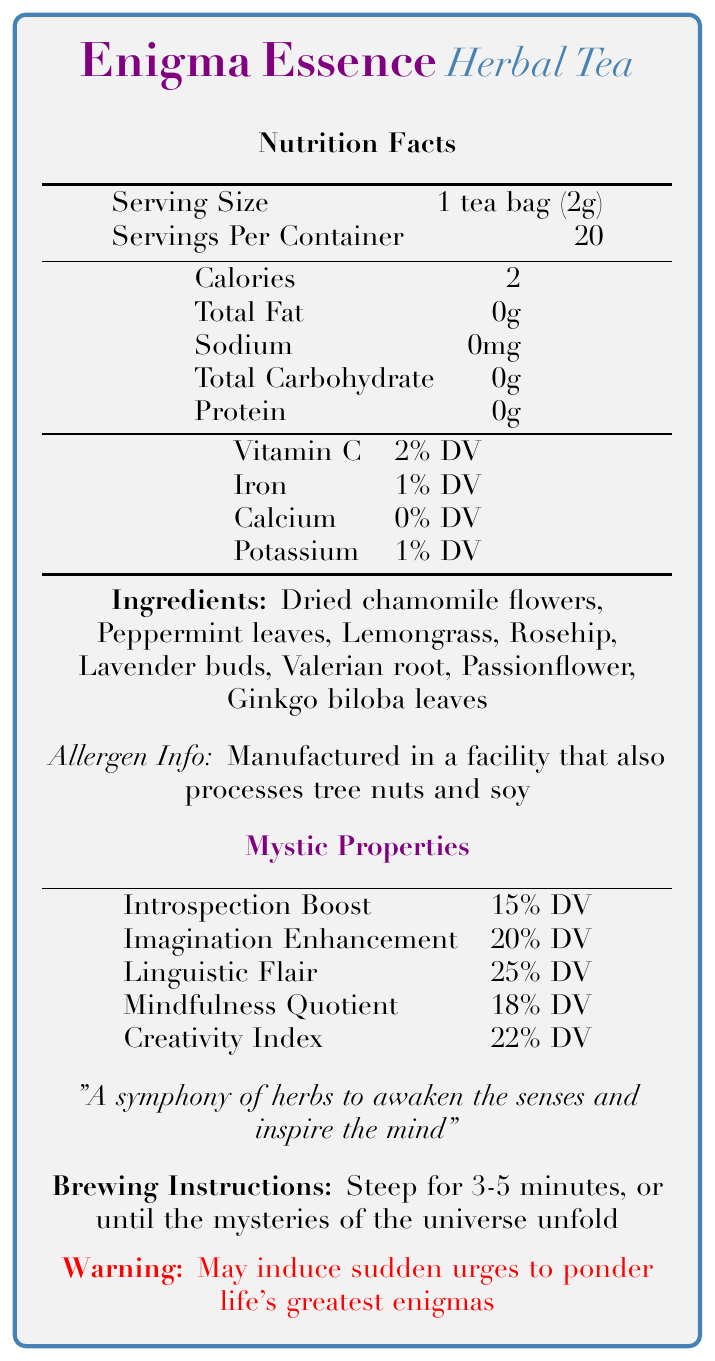what is the serving size of Enigma Essence Herbal Tea? The document states that the serving size is "1 tea bag (2g)."
Answer: 1 tea bag (2g) how many servings are there per container? The document mentions "Servings Per Container" as 20.
Answer: 20 how many calories are present in one serving? The document shows that each serving has "Calories: 2."
Answer: 2 which ingredient is not listed in the tea? A. Valerian root B. Rosehip C. Green tea The provided ingredient list includes Valerian root and Rosehip but not Green tea.
Answer: C how long should you steep the tea? A. 1-2 minutes B. 3-5 minutes C. 6-8 minutes D. 10-12 minutes The brewing instructions recommend steeping for "3-5 minutes."
Answer: B can the tea induce sudden urges to ponder life’s greatest enigmas? The document includes a warning that the tea "may induce sudden urges to ponder life's greatest enigmas."
Answer: Yes describe the aroma profile of Enigma Essence Herbal Tea The document describes the aroma profile as "Notes of contemplation with hints of whimsy."
Answer: Notes of contemplation with hints of whimsy what is the poetic inspiration probability after consuming this tea? The document gives a "30% chance of composing a haiku within 1 hour of consumption."
Answer: 30% chance of composing a haiku within 1 hour of consumption does the tea contain Vitamin C? The document lists Vitamin C with a value of "2% DV."
Answer: Yes what are the percentages of mindfulness quotient and creativity index? The document states "Mindfulness Quotient: 18% DV" and "Creativity Index: 22% DV."
Answer: Mindfulness Quotient: 18% DV, Creativity Index: 22% DV can you find out where the tea is manufactured from this document? The document does not provide details about the manufacturing location.
Answer: Not enough information is there any information regarding allergen content? The document states that the product is "Manufactured in a facility that also processes tree nuts and soy."
Answer: Yes what types of literature might this tea be best paired with? A. Introspective literature B. Science fiction C. Historical fiction The document mentions that the tea pairs well with "introspective literature."
Answer: A summarize the main idea of the document The document provides nutritional details, ingredients, and poetic aspects, emphasizing the tea's introspective and imaginative properties.
Answer: A poetic and mystic description of Enigma Essence Herbal Tea, including its nutritional facts, ingredients, brewing instructions, and its imaginative and introspective effects 